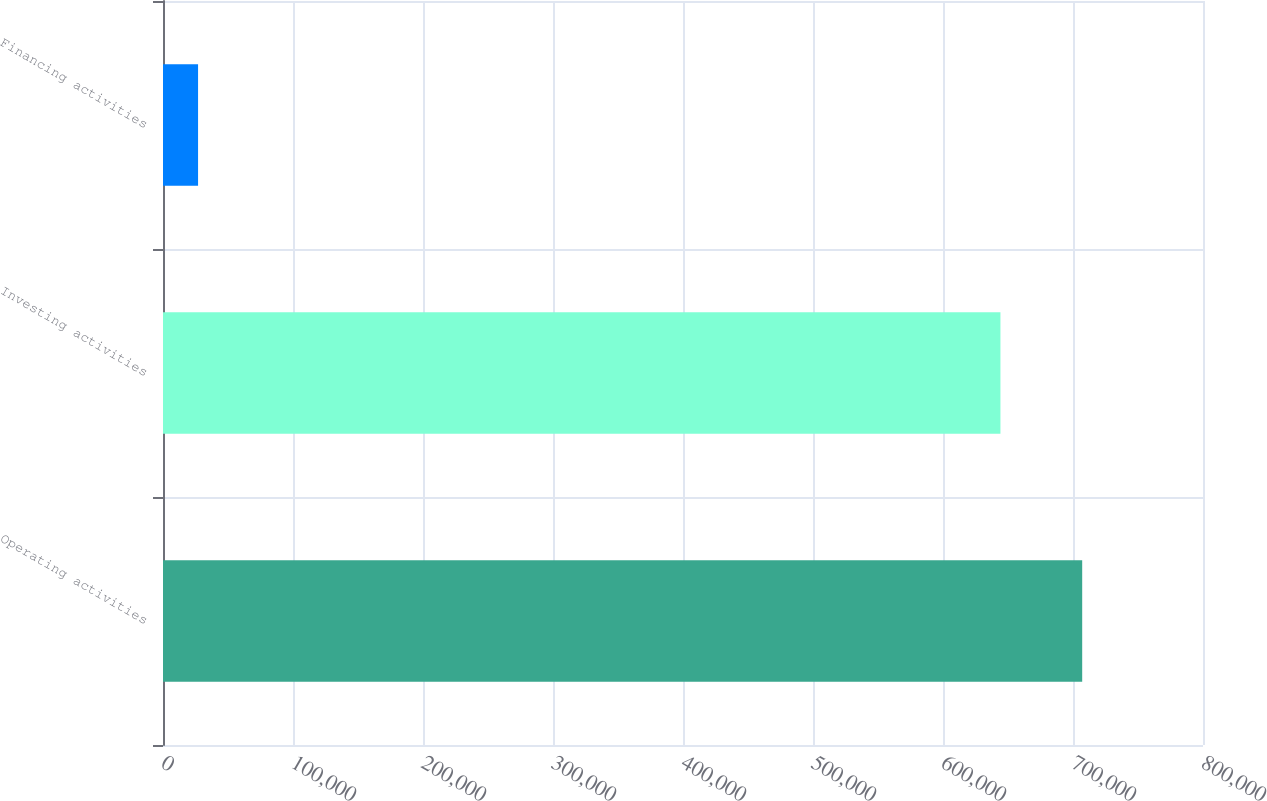Convert chart. <chart><loc_0><loc_0><loc_500><loc_500><bar_chart><fcel>Operating activities<fcel>Investing activities<fcel>Financing activities<nl><fcel>707071<fcel>644180<fcel>26974<nl></chart> 